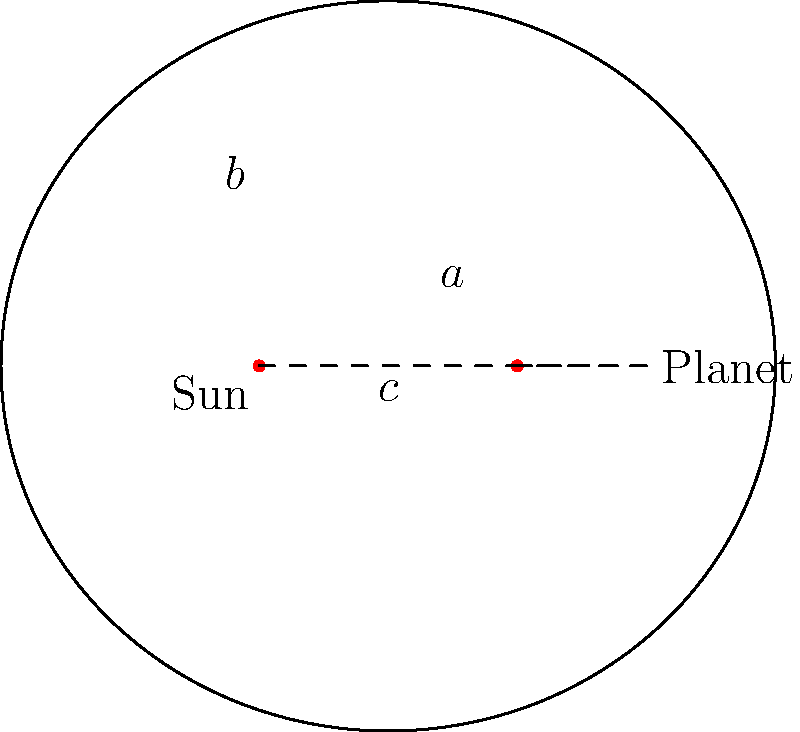In the elliptical orbit of a planet around the sun, how can we express the semi-minor axis (b) in terms of the semi-major axis (a) and the distance between the foci (c)? This relationship is crucial for understanding orbital dynamics and could help in predicting customer behavior patterns in cyclical markets. To find the relationship between the semi-minor axis (b), semi-major axis (a), and the distance between the foci (c) in an elliptical orbit, we can follow these steps:

1. Recall the fundamental equation of an ellipse: $a^2 = b^2 + c^2$

2. We want to express b in terms of a and c, so let's rearrange the equation:
   $b^2 = a^2 - c^2$

3. Take the square root of both sides:
   $b = \sqrt{a^2 - c^2}$

4. This equation gives us the semi-minor axis (b) in terms of the semi-major axis (a) and the distance between the foci (c).

5. In the context of planetary orbits:
   - a represents the average distance of the planet from the sun
   - c is half the distance between the two foci (one of which is the sun)
   - b determines the "width" of the orbit perpendicular to the major axis

6. This relationship is crucial in astronomy for describing orbital shapes and can be analogous to understanding cyclical patterns in customer behavior, where 'a' might represent the average trend, 'c' the deviation from the mean, and 'b' the range of variation in customer responses.
Answer: $b = \sqrt{a^2 - c^2}$ 